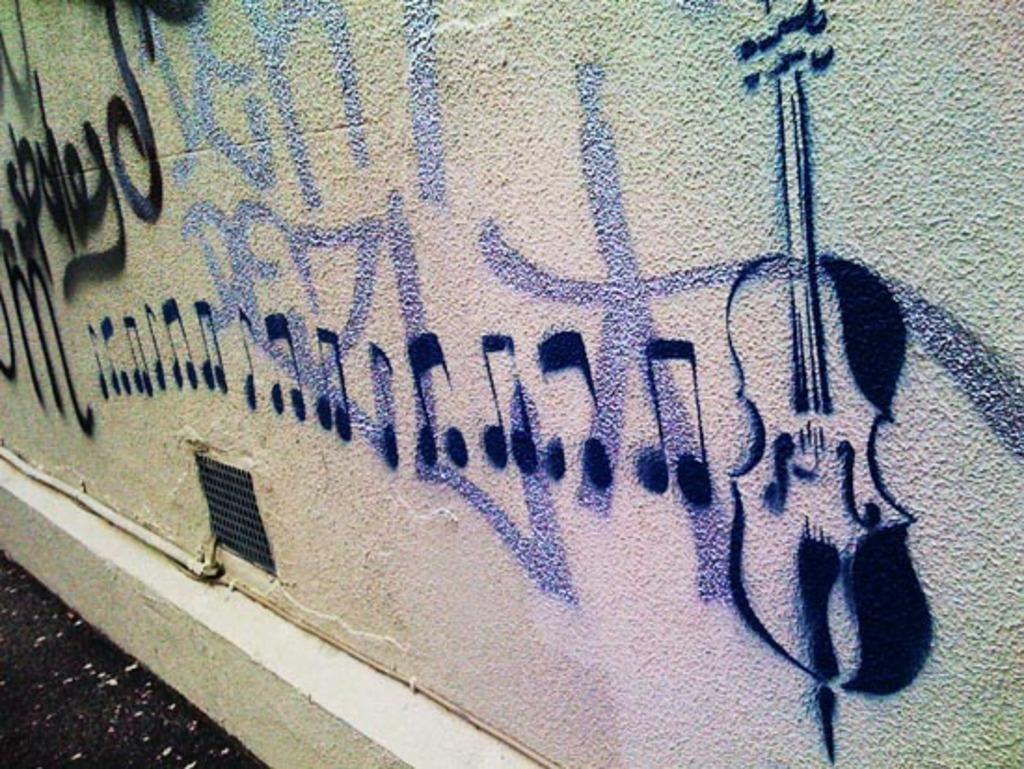Describe this image in one or two sentences. In this picture we can see a pipe, mesh and a wall with a painting of a violin and musical symbols on it. 